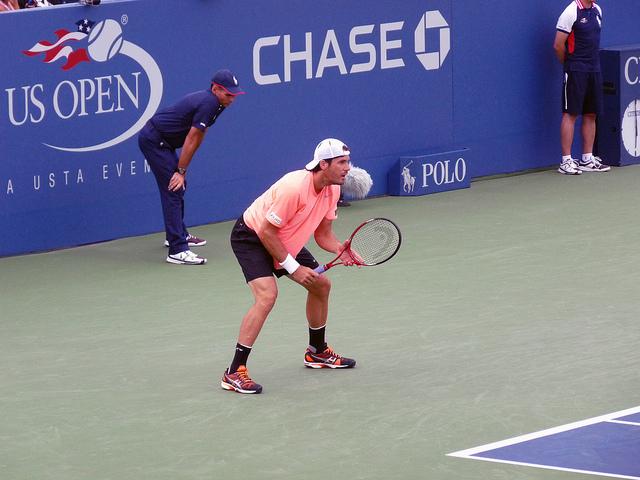Which direction is the man wearing his hat?
Give a very brief answer. Backwards. What sport is being played?
Quick response, please. Tennis. What bank is sponsoring the match?
Concise answer only. Chase. 